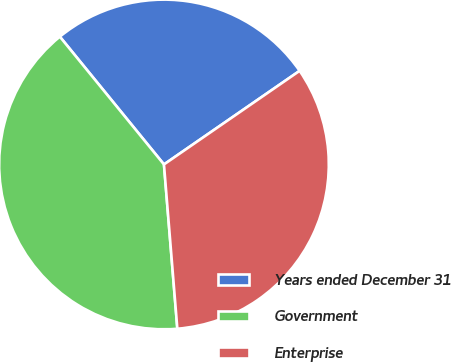<chart> <loc_0><loc_0><loc_500><loc_500><pie_chart><fcel>Years ended December 31<fcel>Government<fcel>Enterprise<nl><fcel>26.27%<fcel>40.41%<fcel>33.32%<nl></chart> 